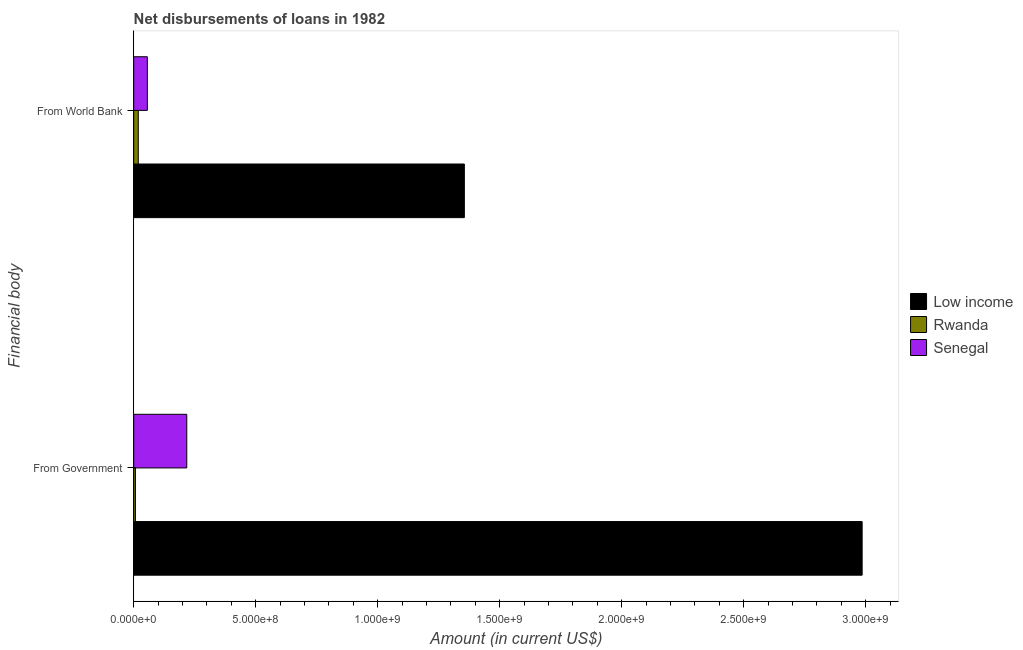How many groups of bars are there?
Your response must be concise. 2. How many bars are there on the 1st tick from the top?
Your answer should be very brief. 3. What is the label of the 1st group of bars from the top?
Your answer should be compact. From World Bank. What is the net disbursements of loan from government in Low income?
Give a very brief answer. 2.99e+09. Across all countries, what is the maximum net disbursements of loan from world bank?
Your answer should be compact. 1.36e+09. Across all countries, what is the minimum net disbursements of loan from government?
Your answer should be very brief. 7.00e+06. In which country was the net disbursements of loan from government minimum?
Provide a short and direct response. Rwanda. What is the total net disbursements of loan from government in the graph?
Your answer should be very brief. 3.21e+09. What is the difference between the net disbursements of loan from world bank in Rwanda and that in Low income?
Your response must be concise. -1.34e+09. What is the difference between the net disbursements of loan from government in Rwanda and the net disbursements of loan from world bank in Senegal?
Your answer should be compact. -4.88e+07. What is the average net disbursements of loan from government per country?
Offer a terse response. 1.07e+09. What is the difference between the net disbursements of loan from world bank and net disbursements of loan from government in Rwanda?
Offer a terse response. 1.16e+07. What is the ratio of the net disbursements of loan from government in Rwanda to that in Low income?
Your answer should be very brief. 0. Is the net disbursements of loan from government in Low income less than that in Rwanda?
Offer a terse response. No. In how many countries, is the net disbursements of loan from government greater than the average net disbursements of loan from government taken over all countries?
Provide a succinct answer. 1. What does the 3rd bar from the top in From World Bank represents?
Give a very brief answer. Low income. What does the 3rd bar from the bottom in From World Bank represents?
Provide a succinct answer. Senegal. What is the difference between two consecutive major ticks on the X-axis?
Provide a short and direct response. 5.00e+08. Where does the legend appear in the graph?
Your answer should be compact. Center right. How many legend labels are there?
Provide a succinct answer. 3. How are the legend labels stacked?
Provide a short and direct response. Vertical. What is the title of the graph?
Provide a succinct answer. Net disbursements of loans in 1982. Does "Kazakhstan" appear as one of the legend labels in the graph?
Keep it short and to the point. No. What is the label or title of the X-axis?
Make the answer very short. Amount (in current US$). What is the label or title of the Y-axis?
Offer a terse response. Financial body. What is the Amount (in current US$) in Low income in From Government?
Give a very brief answer. 2.99e+09. What is the Amount (in current US$) of Rwanda in From Government?
Your answer should be very brief. 7.00e+06. What is the Amount (in current US$) in Senegal in From Government?
Your answer should be very brief. 2.17e+08. What is the Amount (in current US$) in Low income in From World Bank?
Provide a succinct answer. 1.36e+09. What is the Amount (in current US$) in Rwanda in From World Bank?
Make the answer very short. 1.86e+07. What is the Amount (in current US$) of Senegal in From World Bank?
Your response must be concise. 5.58e+07. Across all Financial body, what is the maximum Amount (in current US$) in Low income?
Keep it short and to the point. 2.99e+09. Across all Financial body, what is the maximum Amount (in current US$) of Rwanda?
Make the answer very short. 1.86e+07. Across all Financial body, what is the maximum Amount (in current US$) in Senegal?
Your answer should be very brief. 2.17e+08. Across all Financial body, what is the minimum Amount (in current US$) in Low income?
Keep it short and to the point. 1.36e+09. Across all Financial body, what is the minimum Amount (in current US$) in Rwanda?
Ensure brevity in your answer.  7.00e+06. Across all Financial body, what is the minimum Amount (in current US$) of Senegal?
Give a very brief answer. 5.58e+07. What is the total Amount (in current US$) in Low income in the graph?
Give a very brief answer. 4.34e+09. What is the total Amount (in current US$) in Rwanda in the graph?
Your answer should be compact. 2.56e+07. What is the total Amount (in current US$) in Senegal in the graph?
Ensure brevity in your answer.  2.73e+08. What is the difference between the Amount (in current US$) in Low income in From Government and that in From World Bank?
Provide a succinct answer. 1.63e+09. What is the difference between the Amount (in current US$) of Rwanda in From Government and that in From World Bank?
Your answer should be compact. -1.16e+07. What is the difference between the Amount (in current US$) of Senegal in From Government and that in From World Bank?
Ensure brevity in your answer.  1.62e+08. What is the difference between the Amount (in current US$) in Low income in From Government and the Amount (in current US$) in Rwanda in From World Bank?
Your response must be concise. 2.97e+09. What is the difference between the Amount (in current US$) in Low income in From Government and the Amount (in current US$) in Senegal in From World Bank?
Make the answer very short. 2.93e+09. What is the difference between the Amount (in current US$) in Rwanda in From Government and the Amount (in current US$) in Senegal in From World Bank?
Provide a short and direct response. -4.88e+07. What is the average Amount (in current US$) in Low income per Financial body?
Provide a short and direct response. 2.17e+09. What is the average Amount (in current US$) in Rwanda per Financial body?
Your response must be concise. 1.28e+07. What is the average Amount (in current US$) in Senegal per Financial body?
Make the answer very short. 1.37e+08. What is the difference between the Amount (in current US$) of Low income and Amount (in current US$) of Rwanda in From Government?
Your answer should be compact. 2.98e+09. What is the difference between the Amount (in current US$) of Low income and Amount (in current US$) of Senegal in From Government?
Keep it short and to the point. 2.77e+09. What is the difference between the Amount (in current US$) of Rwanda and Amount (in current US$) of Senegal in From Government?
Provide a succinct answer. -2.10e+08. What is the difference between the Amount (in current US$) in Low income and Amount (in current US$) in Rwanda in From World Bank?
Provide a succinct answer. 1.34e+09. What is the difference between the Amount (in current US$) of Low income and Amount (in current US$) of Senegal in From World Bank?
Provide a short and direct response. 1.30e+09. What is the difference between the Amount (in current US$) in Rwanda and Amount (in current US$) in Senegal in From World Bank?
Your response must be concise. -3.72e+07. What is the ratio of the Amount (in current US$) of Low income in From Government to that in From World Bank?
Your response must be concise. 2.2. What is the ratio of the Amount (in current US$) in Rwanda in From Government to that in From World Bank?
Provide a short and direct response. 0.38. What is the ratio of the Amount (in current US$) of Senegal in From Government to that in From World Bank?
Offer a terse response. 3.9. What is the difference between the highest and the second highest Amount (in current US$) in Low income?
Provide a succinct answer. 1.63e+09. What is the difference between the highest and the second highest Amount (in current US$) in Rwanda?
Provide a succinct answer. 1.16e+07. What is the difference between the highest and the second highest Amount (in current US$) of Senegal?
Ensure brevity in your answer.  1.62e+08. What is the difference between the highest and the lowest Amount (in current US$) in Low income?
Your answer should be very brief. 1.63e+09. What is the difference between the highest and the lowest Amount (in current US$) in Rwanda?
Provide a short and direct response. 1.16e+07. What is the difference between the highest and the lowest Amount (in current US$) in Senegal?
Keep it short and to the point. 1.62e+08. 